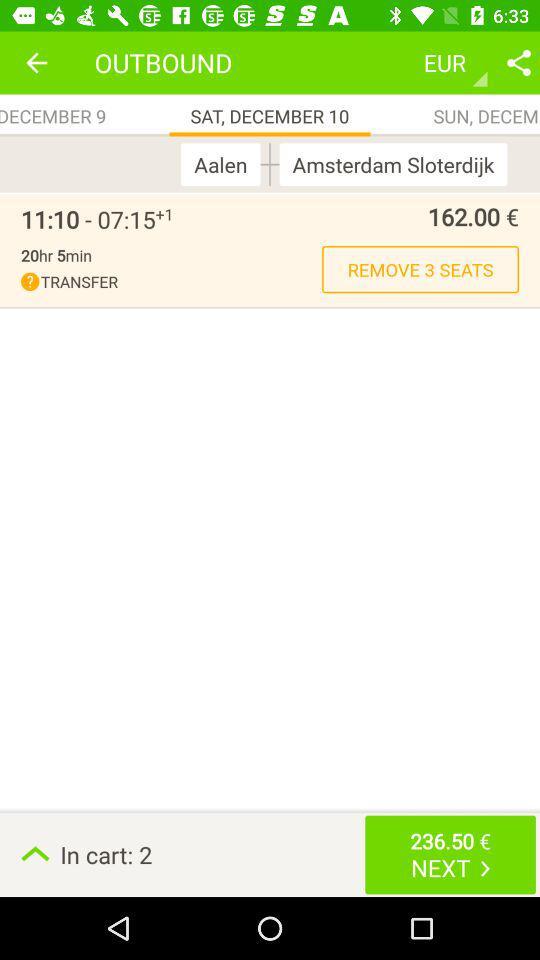How many seats are booked?
When the provided information is insufficient, respond with <no answer>. <no answer> 